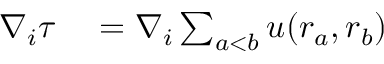Convert formula to latex. <formula><loc_0><loc_0><loc_500><loc_500>\begin{array} { r l } { \nabla _ { i } \tau } & = \nabla _ { i } \sum _ { a < b } u ( r _ { a } , r _ { b } ) } \end{array}</formula> 